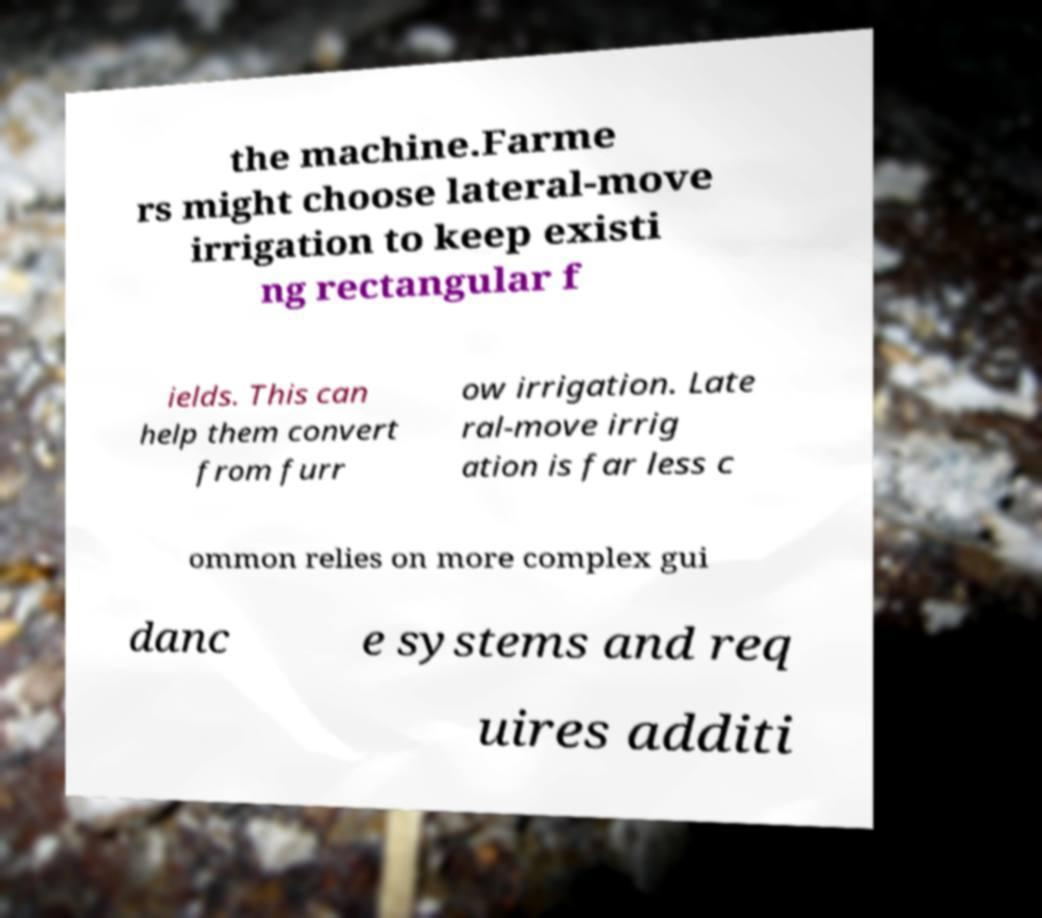Please identify and transcribe the text found in this image. the machine.Farme rs might choose lateral-move irrigation to keep existi ng rectangular f ields. This can help them convert from furr ow irrigation. Late ral-move irrig ation is far less c ommon relies on more complex gui danc e systems and req uires additi 